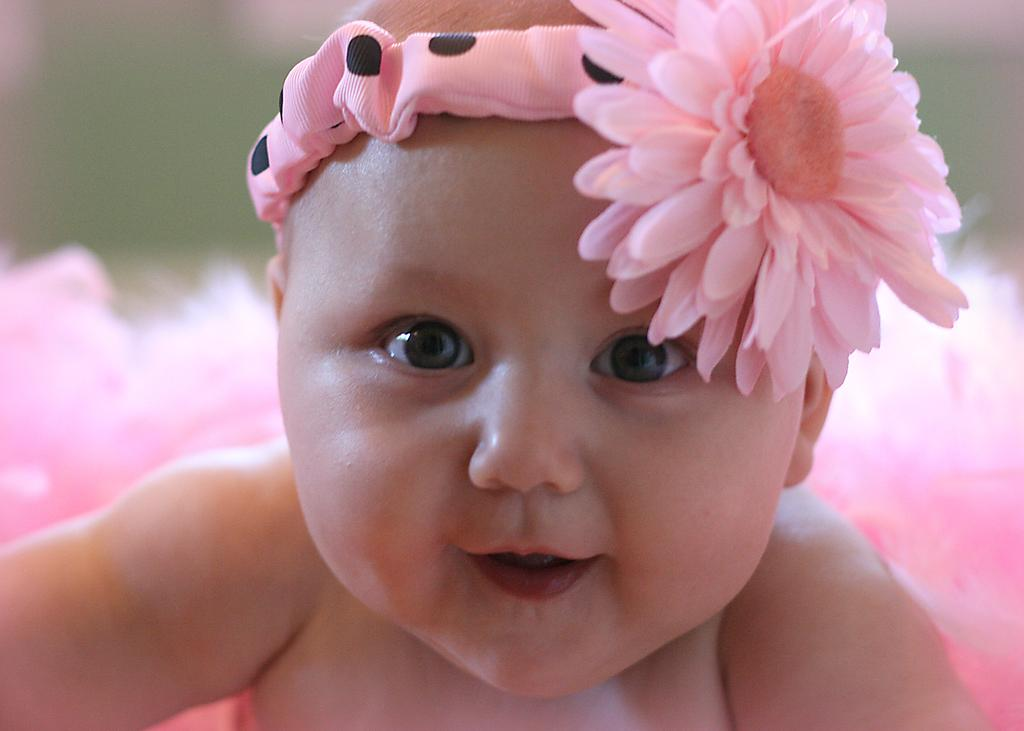What is the main subject of the image? There is a baby in the image. What is the baby doing in the image? The baby is smiling. What is the baby wearing on their head? The baby is wearing a headband. What is on the headband? The headband has a flower. What color is the flower? The flower is pink in color. How would you describe the background of the image? The background of the image appears blurry. What type of fang can be seen in the baby's mouth in the image? There are no fangs visible in the baby's mouth in the image. Is there a notebook on the baby's lap in the image? There is no notebook present in the image. 